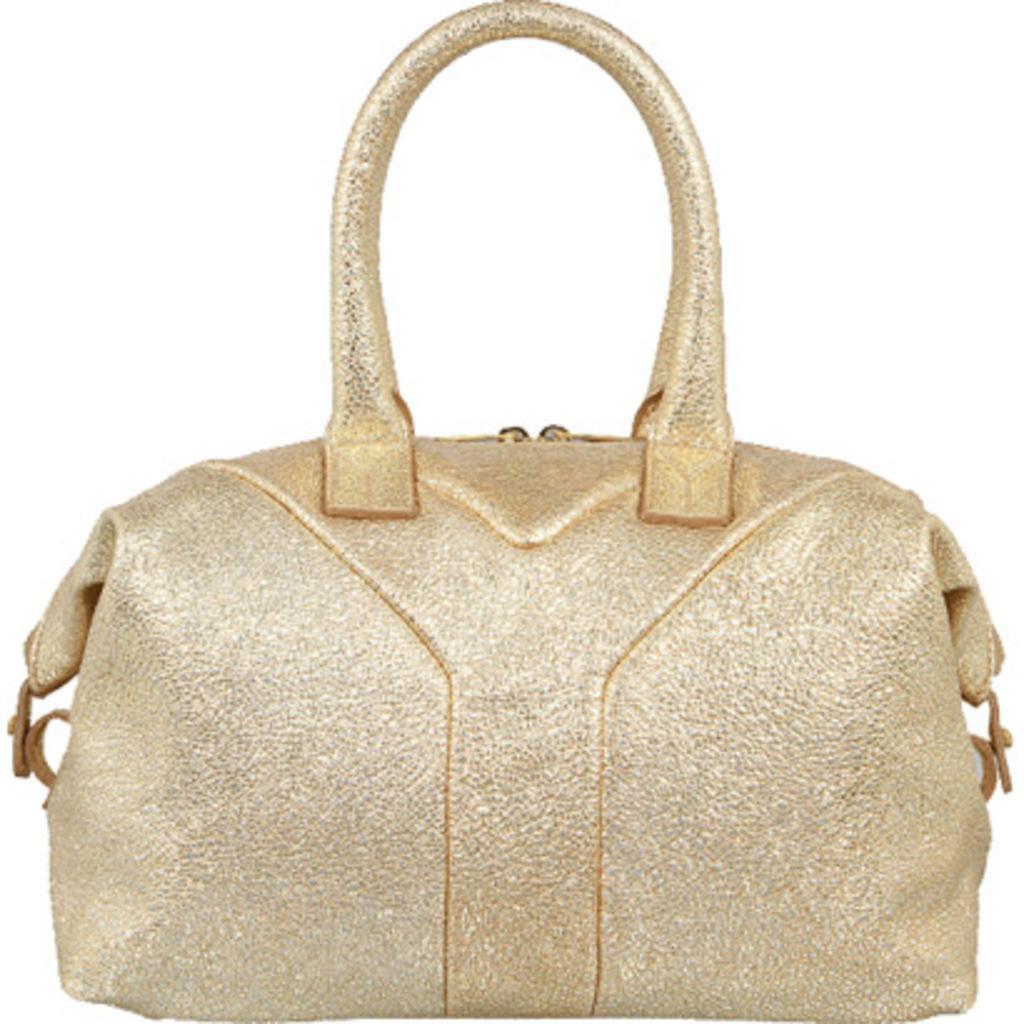Describe this image in one or two sentences. There is a handbag with golden color. 